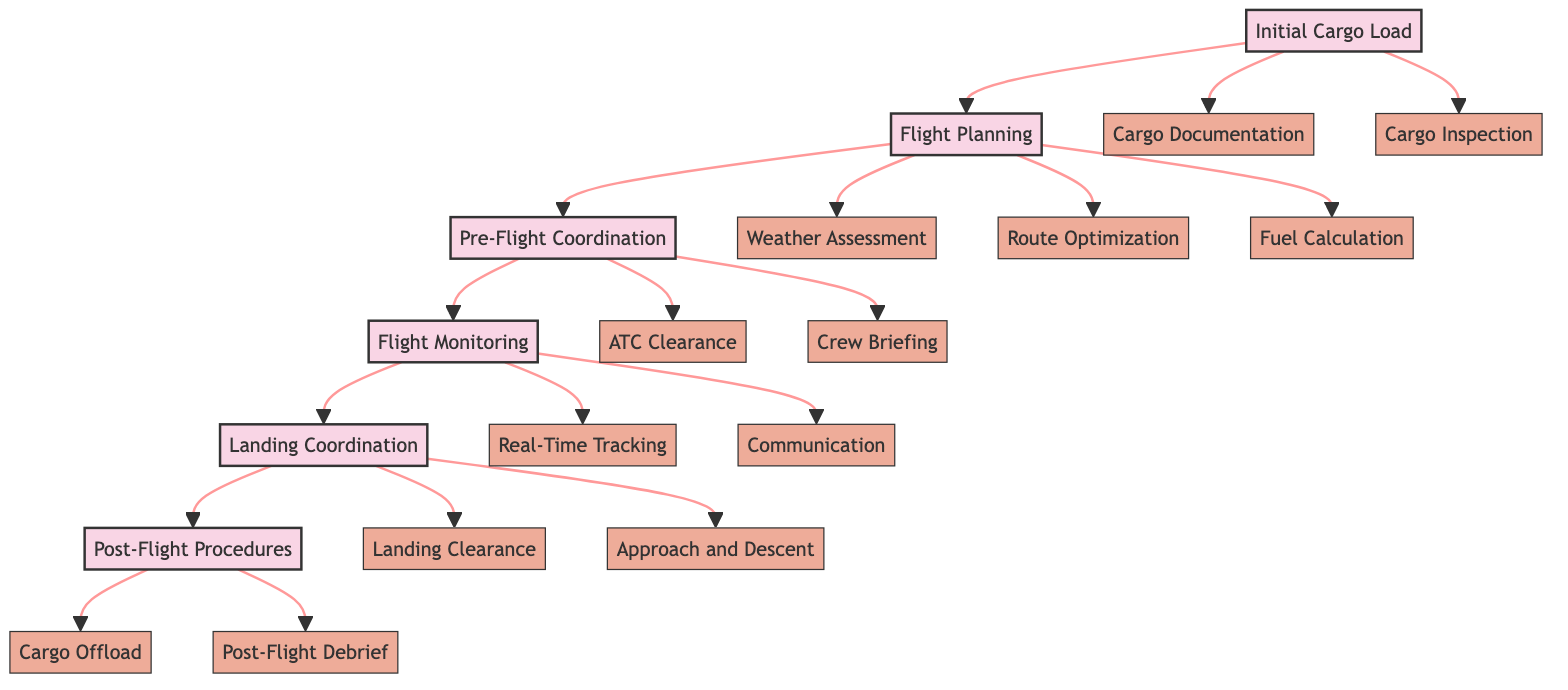What is the first step in the flight coordination workflow? The diagram indicates that "Initial Cargo Load" is the first step in the workflow, as it is the first element connected to subsequent steps.
Answer: Initial Cargo Load How many main steps are there in the flight coordination workflow? The diagram shows a total of six main steps: Initial Cargo Load, Flight Planning, Pre-Flight Coordination, Flight Monitoring, Landing Coordination, and Post-Flight Procedures.
Answer: 6 What are the sub-elements of "Flight Monitoring"? The diagram outlines "Real-Time Tracking" and "Communication" as the sub-elements under the "Flight Monitoring" step.
Answer: Real-Time Tracking and Communication Which step comes after "Pre-Flight Coordination"? According to the flowchart structure, "Flight Monitoring" follows "Pre-Flight Coordination," indicating the order of operations.
Answer: Flight Monitoring What action is required under "Landing Coordination"? The sub-elements under "Landing Coordination" include obtaining "Landing Clearance" and managing "Approach and Descent," which are both necessary actions in this step.
Answer: Landing Clearance and Approach and Descent What is the purpose of the "Cargo Documentation" sub-element? The "Cargo Documentation" ensures that the verification of the cargo manifest and relevant documents is performed as part of the Initial Cargo Load.
Answer: Verification of cargo manifest and relevant documents What is needed for safe landing according to "Landing Coordination"? "Landing Clearance" from the destination airport's ATC is necessary for achieving safe landing, as indicated by its placement within the "Landing Coordination" step.
Answer: Landing Clearance Which elements are involved in "Flight Planning"? "Weather Assessment," "Route Optimization," and "Fuel Calculation" are the sub-elements listed under "Flight Planning," contributing to the planning process.
Answer: Weather Assessment, Route Optimization, and Fuel Calculation What does the "Post-Flight Procedures" step entail? The two sub-elements: "Cargo Offload" and "Post-Flight Debrief" represent the activities conducted after the aircraft has landed, indicating the responsibilities in this step.
Answer: Cargo Offload and Post-Flight Debrief 